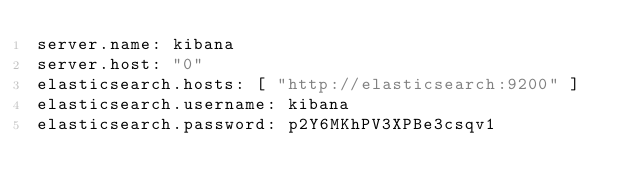Convert code to text. <code><loc_0><loc_0><loc_500><loc_500><_YAML_>server.name: kibana
server.host: "0"
elasticsearch.hosts: [ "http://elasticsearch:9200" ]
elasticsearch.username: kibana
elasticsearch.password: p2Y6MKhPV3XPBe3csqv1
</code> 